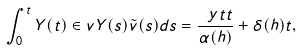Convert formula to latex. <formula><loc_0><loc_0><loc_500><loc_500>\int _ { 0 } ^ { t } Y ( t ) \in v { Y } ( s ) \tilde { v } ( s ) d s = \frac { \ y t { t } } { \alpha ( h ) } + \delta ( h ) t ,</formula> 